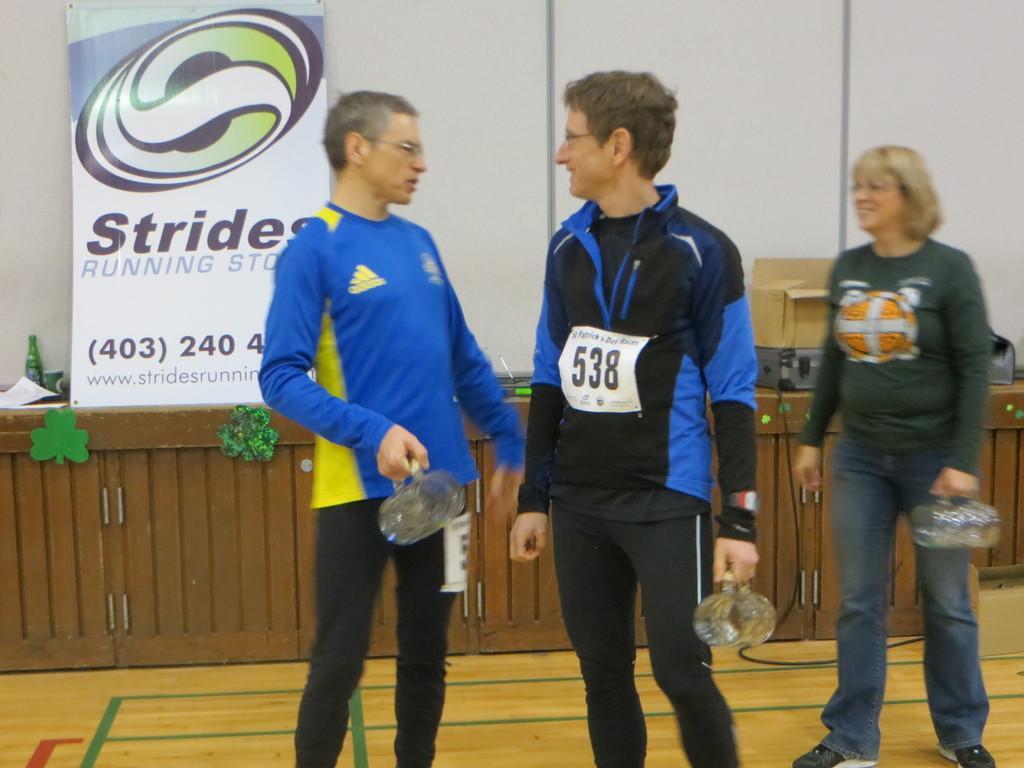Please provide a concise description of this image. In this image I can see three people are standing holding something in their hands. In the background I can see a wall and a banner on which I can see something written on it. On the wooden platform I can see a bottle and other objects. 